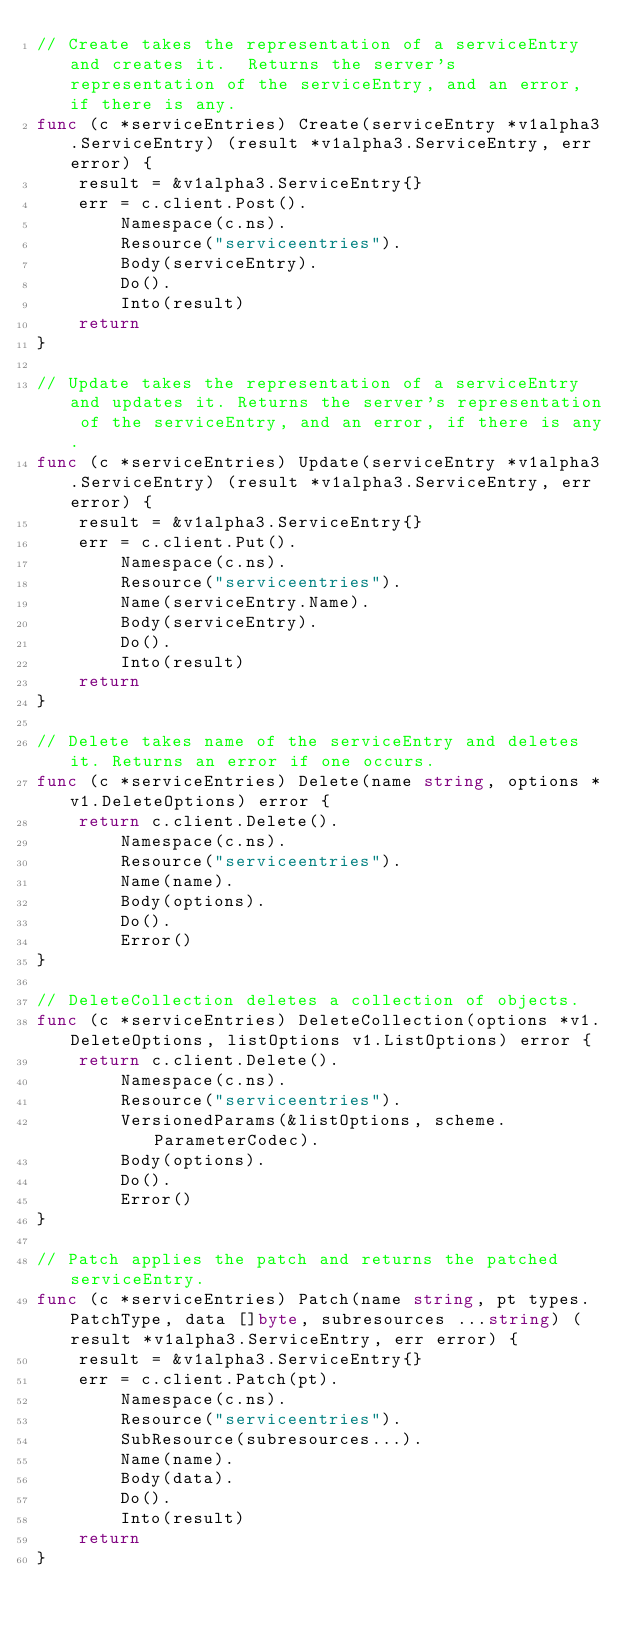Convert code to text. <code><loc_0><loc_0><loc_500><loc_500><_Go_>// Create takes the representation of a serviceEntry and creates it.  Returns the server's representation of the serviceEntry, and an error, if there is any.
func (c *serviceEntries) Create(serviceEntry *v1alpha3.ServiceEntry) (result *v1alpha3.ServiceEntry, err error) {
	result = &v1alpha3.ServiceEntry{}
	err = c.client.Post().
		Namespace(c.ns).
		Resource("serviceentries").
		Body(serviceEntry).
		Do().
		Into(result)
	return
}

// Update takes the representation of a serviceEntry and updates it. Returns the server's representation of the serviceEntry, and an error, if there is any.
func (c *serviceEntries) Update(serviceEntry *v1alpha3.ServiceEntry) (result *v1alpha3.ServiceEntry, err error) {
	result = &v1alpha3.ServiceEntry{}
	err = c.client.Put().
		Namespace(c.ns).
		Resource("serviceentries").
		Name(serviceEntry.Name).
		Body(serviceEntry).
		Do().
		Into(result)
	return
}

// Delete takes name of the serviceEntry and deletes it. Returns an error if one occurs.
func (c *serviceEntries) Delete(name string, options *v1.DeleteOptions) error {
	return c.client.Delete().
		Namespace(c.ns).
		Resource("serviceentries").
		Name(name).
		Body(options).
		Do().
		Error()
}

// DeleteCollection deletes a collection of objects.
func (c *serviceEntries) DeleteCollection(options *v1.DeleteOptions, listOptions v1.ListOptions) error {
	return c.client.Delete().
		Namespace(c.ns).
		Resource("serviceentries").
		VersionedParams(&listOptions, scheme.ParameterCodec).
		Body(options).
		Do().
		Error()
}

// Patch applies the patch and returns the patched serviceEntry.
func (c *serviceEntries) Patch(name string, pt types.PatchType, data []byte, subresources ...string) (result *v1alpha3.ServiceEntry, err error) {
	result = &v1alpha3.ServiceEntry{}
	err = c.client.Patch(pt).
		Namespace(c.ns).
		Resource("serviceentries").
		SubResource(subresources...).
		Name(name).
		Body(data).
		Do().
		Into(result)
	return
}
</code> 